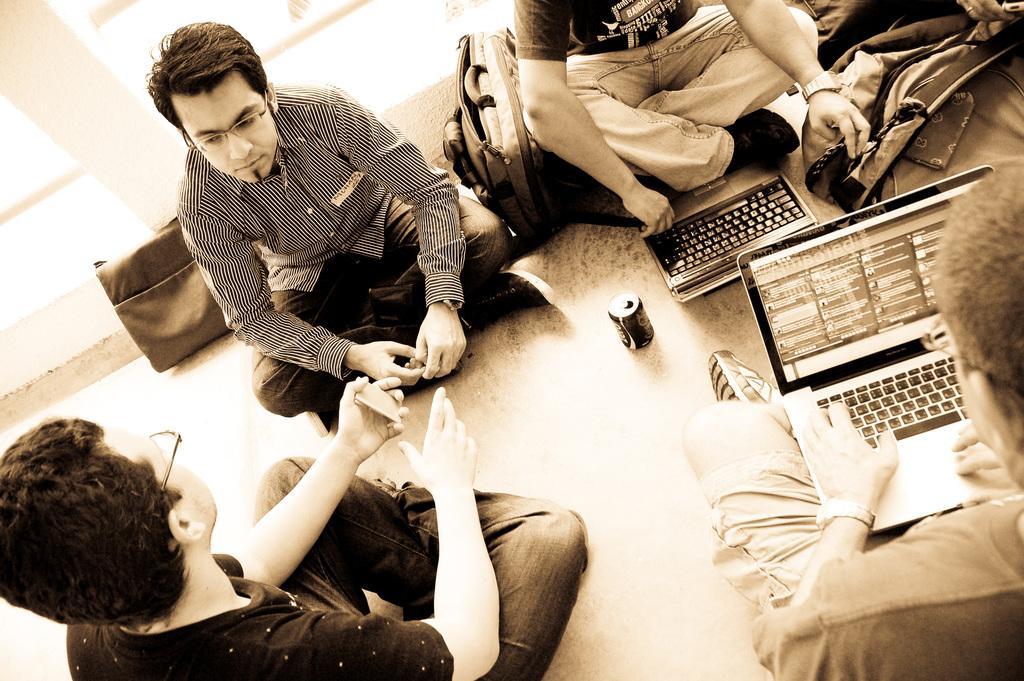Could you give a brief overview of what you see in this image? In the foreground of this image, on the floor there are few people sitting and also we can see two bags, laptops, a tin and an object in the right top corner. 